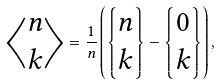Convert formula to latex. <formula><loc_0><loc_0><loc_500><loc_500>\left \langle \begin{matrix} n \\ k \end{matrix} \right \rangle = \frac { 1 } { n } \left ( \left \{ \begin{matrix} n \\ k \end{matrix} \right \} - \left \{ \begin{matrix} 0 \\ k \end{matrix} \right \} \right ) ,</formula> 